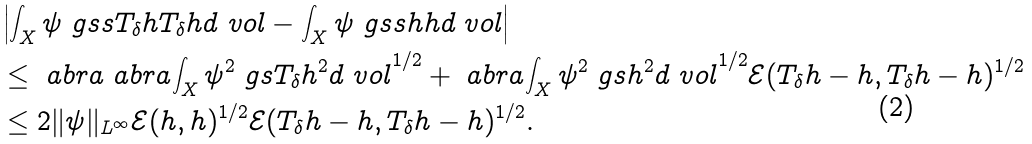Convert formula to latex. <formula><loc_0><loc_0><loc_500><loc_500>& \left | \int _ { X } \psi \ g s s { T _ { \delta } h } { T _ { \delta } h } d \ v o l - \int _ { X } \psi \ g s s { h } { h } d \ v o l \right | \\ & \leq \ a b r a { \ a b r a { \int _ { X } \psi ^ { 2 } \ g s { T _ { \delta } h } ^ { 2 } d \ v o l } ^ { 1 / 2 } + \ a b r a { \int _ { X } \psi ^ { 2 } \ g s { h } ^ { 2 } d \ v o l } ^ { 1 / 2 } } \mathcal { E } ( T _ { \delta } h - h , T _ { \delta } h - h ) ^ { 1 / 2 } \\ & \leq 2 \| \psi \| _ { L ^ { \infty } } \mathcal { E } ( h , h ) ^ { 1 / 2 } \mathcal { E } ( T _ { \delta } h - h , T _ { \delta } h - h ) ^ { 1 / 2 } .</formula> 